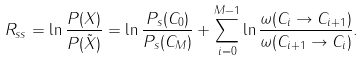<formula> <loc_0><loc_0><loc_500><loc_500>R _ { s s } = \ln \frac { P ( { X } ) } { P ( { \tilde { X } } ) } = \ln \frac { P _ { s } ( C _ { 0 } ) } { P _ { s } ( C _ { M } ) } + \sum _ { i = 0 } ^ { M - 1 } \ln \frac { \omega ( C _ { i } \to C _ { i + 1 } ) } { \omega ( C _ { i + 1 } \to C _ { i } ) } .</formula> 